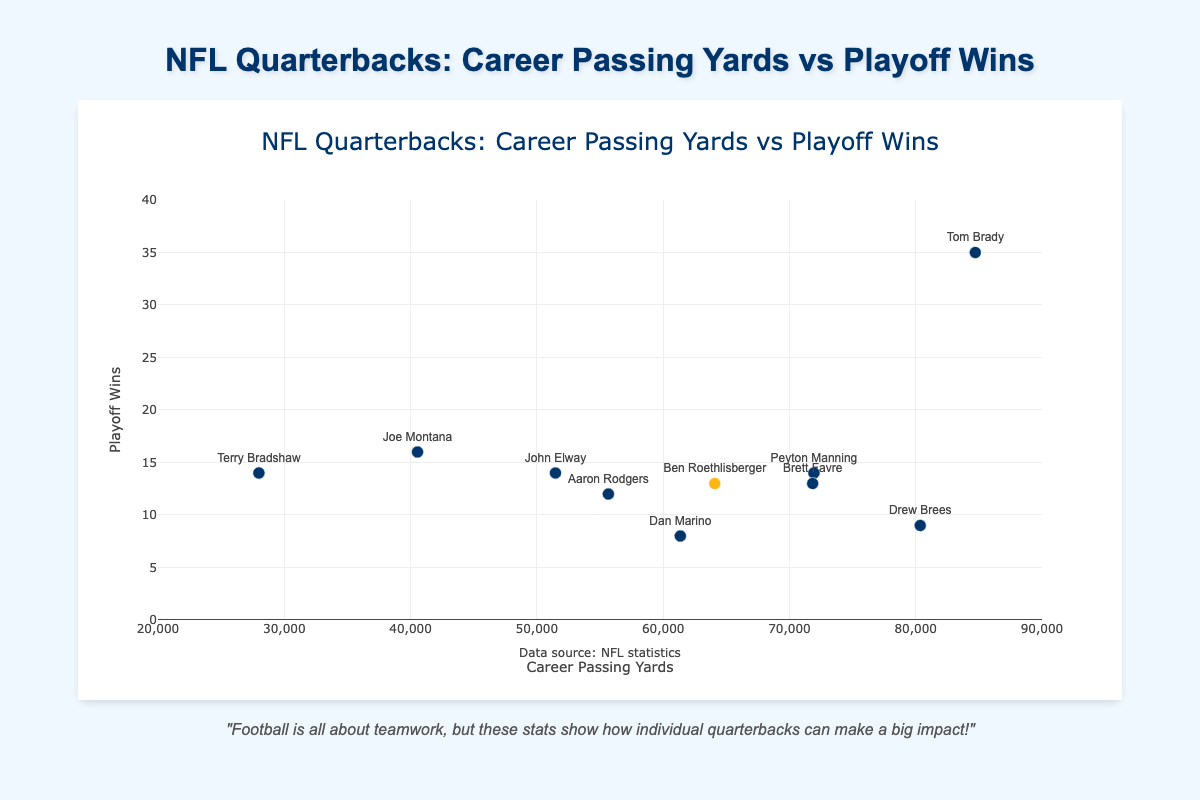Which quarterback has the highest career passing yards? According to the scatter plot, Tom Brady has the highest career passing yards compared to other quarterbacks.
Answer: Tom Brady How many playoff wins does Ben Roethlisberger have? By looking at the scatter plot, you can find Ben Roethlisberger's data point positioned at 13 playoff wins.
Answer: 13 What is the relationship between career passing yards and playoff wins? The scatter plot shows a positive trend between career passing yards and playoff wins, suggesting that quarterbacks with more passing yards tend to have more playoff wins, though there are some exceptions.
Answer: Positive trend Which quarterback has more playoff wins, Peyton Manning or John Elway? From the scatter plot, Peyton Manning and John Elway both have 14 playoff wins.
Answer: Equal (14) What are the career passing yards and playoff wins of Brett Favre? Brett Favre's data point on the scatter plot is located at 71,838 career passing yards and 13 playoff wins.
Answer: 71,838 career passing yards and 13 playoff wins Who has the fewest career passing yards among the quarterbacks listed? The scatter plot indicates that Terry Bradshaw has the fewest career passing yards among the quarterbacks shown, with 27,989 yards.
Answer: Terry Bradshaw How many quarterbacks have more than 70,000 career passing yards? By examining the scatter plot, there are three quarterbacks with more than 70,000 career passing yards: Tom Brady, Peyton Manning, and Drew Brees.
Answer: 3 Compare Ben Roethlisberger and Aaron Rodgers in terms of playoff wins and career passing yards. In the scatter plot, Ben Roethlisberger has more career passing yards (64,088 vs. 55,663) and also more playoff wins (13 vs. 12) compared to Aaron Rodgers.
Answer: Ben Roethlisberger Which quarterback stands out for having high playoff wins but lower career passing yards? The scatter plot shows Joe Montana as having 16 playoff wins, which is high, but his career passing yards are 40,551, which is lower compared to others with similar playoff wins.
Answer: Joe Montana How many quarterbacks have 14 playoff wins and who are they? According to the scatter plot, there are three quarterbacks with 14 playoff wins: Peyton Manning, John Elway, and Terry Bradshaw.
Answer: 3 (Peyton Manning, John Elway, Terry Bradshaw) 